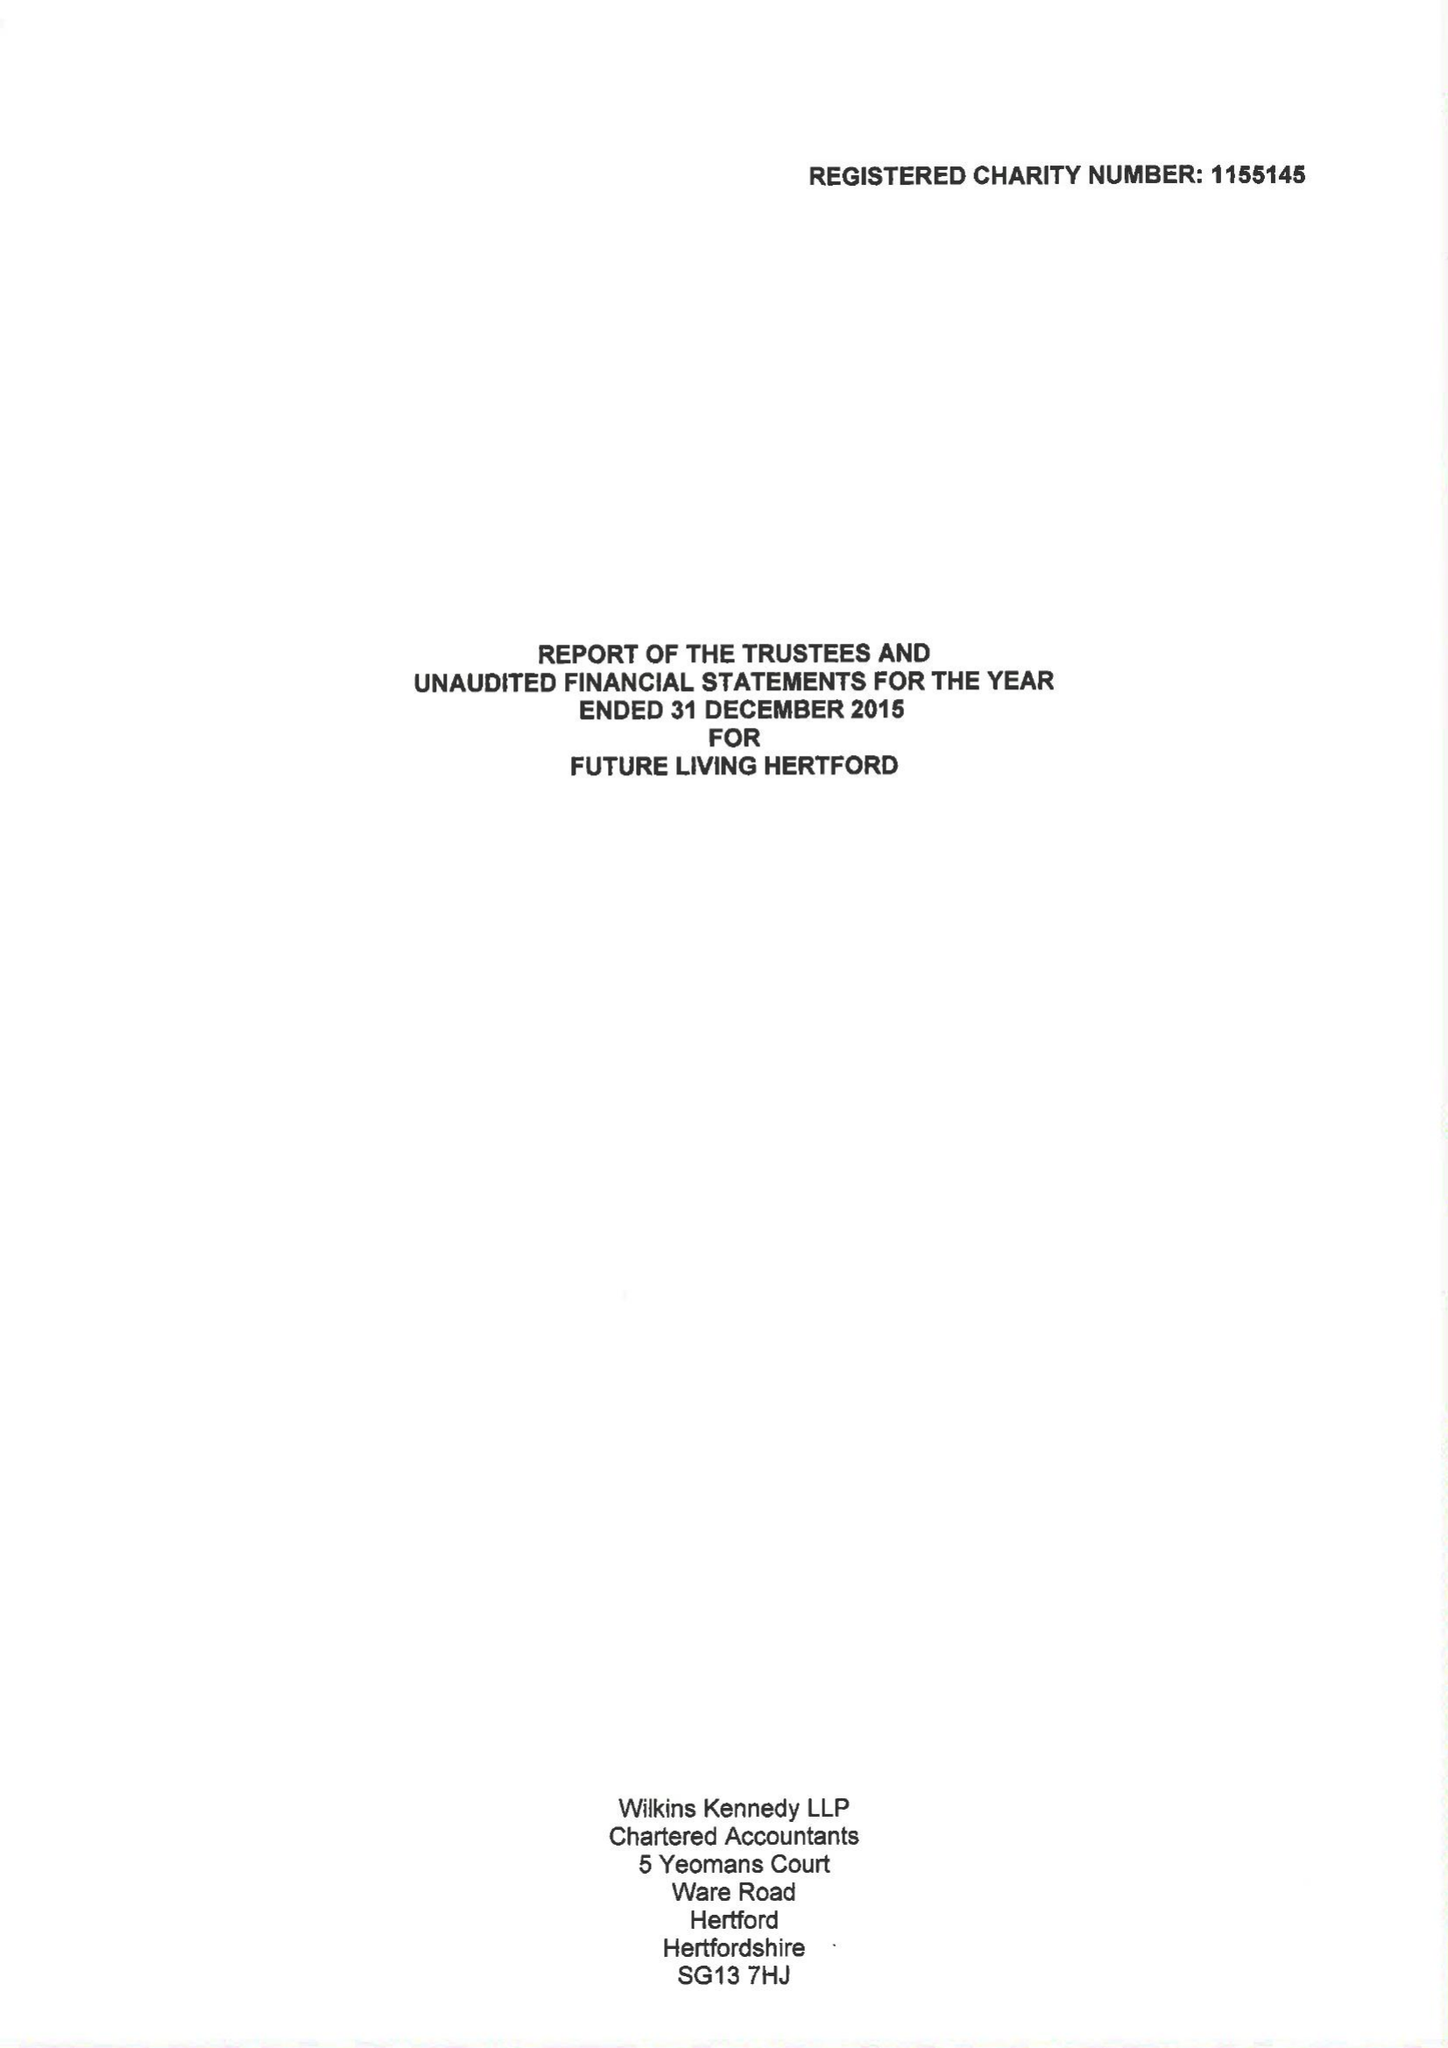What is the value for the income_annually_in_british_pounds?
Answer the question using a single word or phrase. 58712.00 